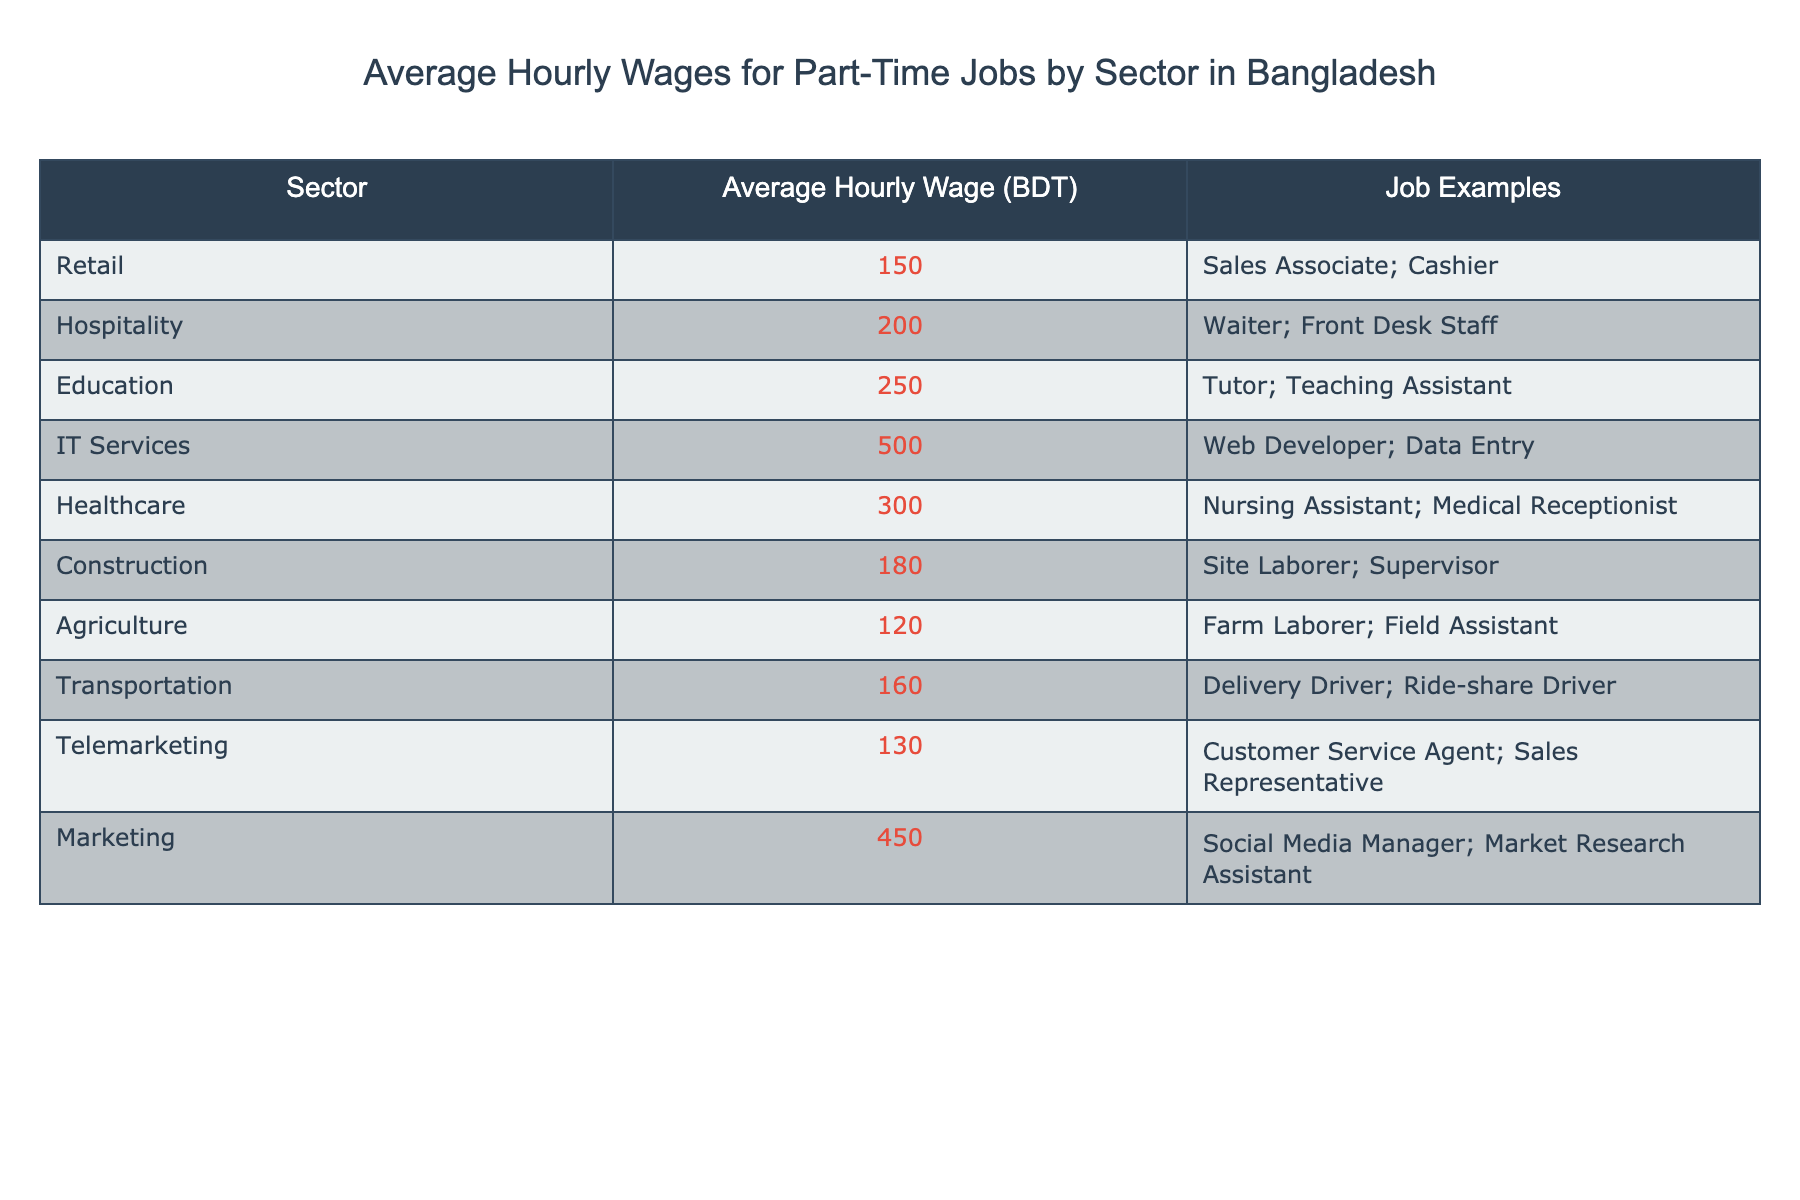What is the average hourly wage for a Retail job? The table lists the average hourly wage for the Retail sector as 150 BDT.
Answer: 150 BDT Which sector has the highest average hourly wage? By comparing the average hourly wages in the table, IT Services has the highest wage at 500 BDT.
Answer: IT Services What are some job examples in the Healthcare sector? The table indicates that Nursing Assistant and Medical Receptionist are examples of jobs in the Healthcare sector.
Answer: Nursing Assistant; Medical Receptionist What is the average hourly wage for part-time jobs in the Agriculture sector? According to the table, the average hourly wage for the Agriculture sector is 120 BDT.
Answer: 120 BDT Which sector offers an average hourly wage of 200 BDT? The table specifies that the Hospitality sector has an average hourly wage of 200 BDT.
Answer: Hospitality If I worked 10 hours in IT Services, how much would I earn? The average hourly wage in IT Services is 500 BDT. Therefore, for 10 hours, I would earn 500 BDT * 10 = 5000 BDT.
Answer: 5000 BDT What is the difference in average hourly wages between the Education and Telemarketing sectors? Education has an average wage of 250 BDT, while Telemarketing has 130 BDT. The difference is 250 BDT - 130 BDT = 120 BDT.
Answer: 120 BDT Is the average hourly wage for part-time jobs in Marketing higher than in Healthcare? Marketing has an average wage of 450 BDT and Healthcare has 300 BDT. Since 450 BDT > 300 BDT, the answer is yes.
Answer: Yes What is the median average hourly wage among all sectors? First, list the wages: 120, 130, 150, 160, 180, 200, 250, 300, 450, 500. The median (the middle number in sorted data) is the average of the 5th and 6th values: (180 + 200)/2 = 190.
Answer: 190 BDT Which sector has the lowest average hourly wage and what is it? The table shows that Agriculture has the lowest average hourly wage at 120 BDT.
Answer: Agriculture, 120 BDT How much more does a job in IT Services pay on average compared to Agriculture? IT Services pays 500 BDT and Agriculture pays 120 BDT. The difference is 500 BDT - 120 BDT = 380 BDT.
Answer: 380 BDT 